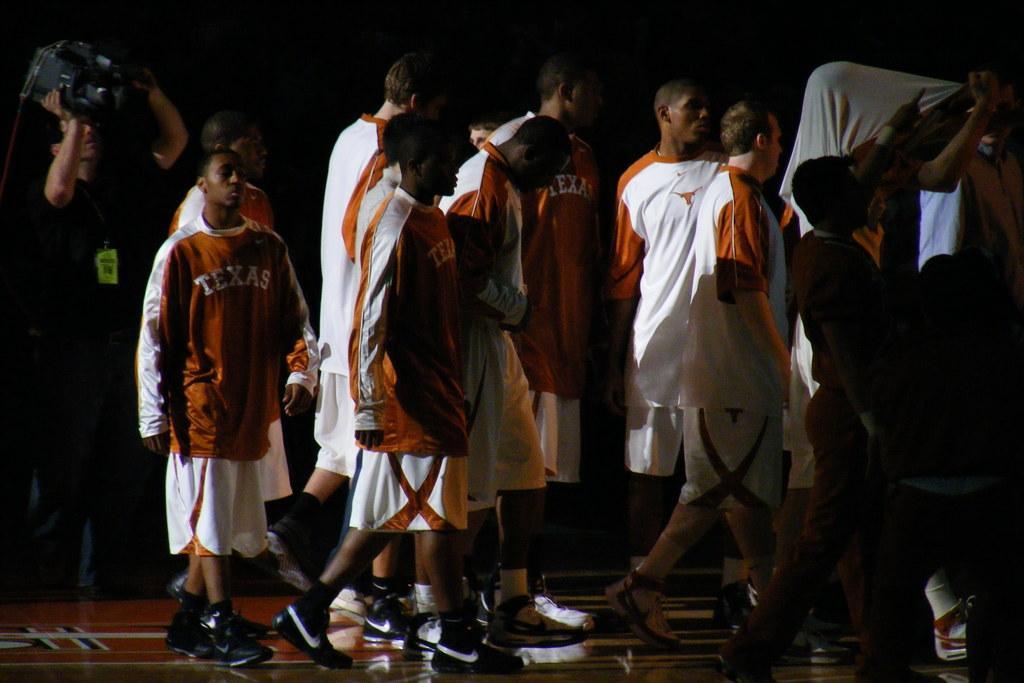Could you give a brief overview of what you see in this image? In the picture I can see a group of people are standing. The man on the left side is holding a video camera in hands. The background of the image is dark. 